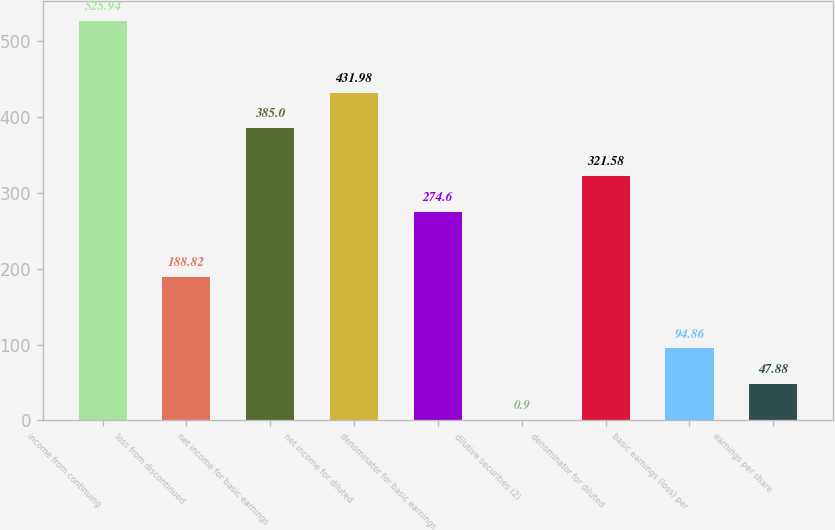Convert chart to OTSL. <chart><loc_0><loc_0><loc_500><loc_500><bar_chart><fcel>income from continuing<fcel>loss from discontinued<fcel>net income for basic earnings<fcel>net income for diluted<fcel>denominator for basic earnings<fcel>dilutive securities (2)<fcel>denominator for diluted<fcel>basic earnings (loss) per<fcel>earnings per share<nl><fcel>525.94<fcel>188.82<fcel>385<fcel>431.98<fcel>274.6<fcel>0.9<fcel>321.58<fcel>94.86<fcel>47.88<nl></chart> 